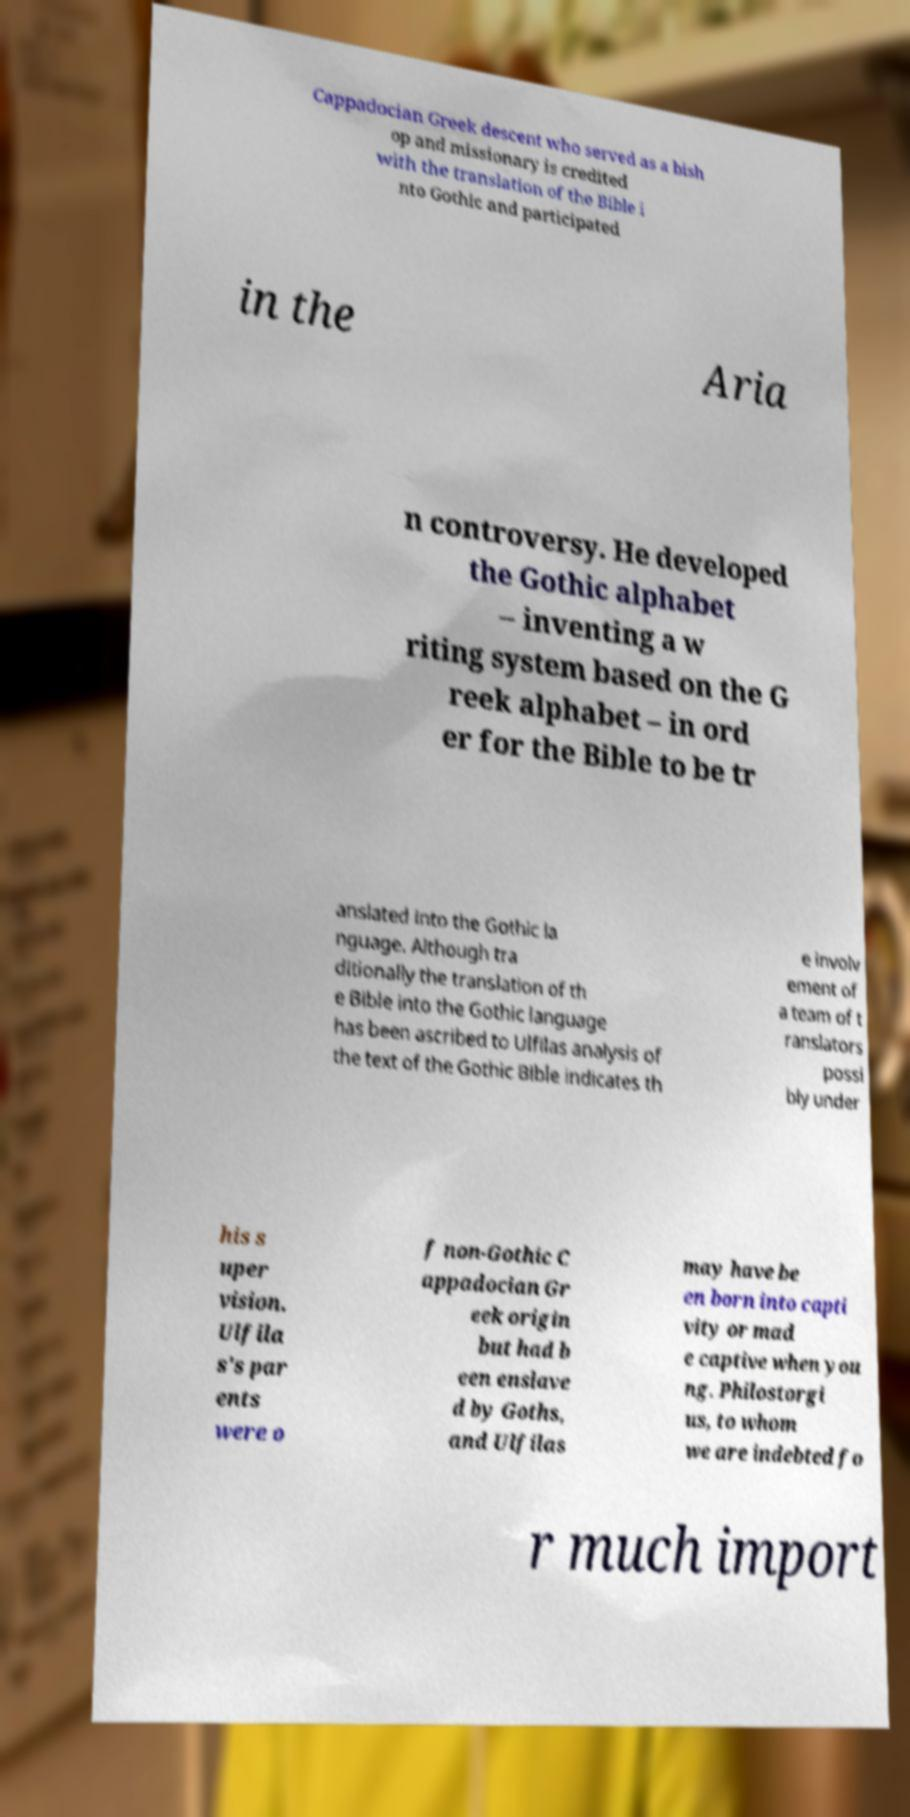Can you accurately transcribe the text from the provided image for me? Cappadocian Greek descent who served as a bish op and missionary is credited with the translation of the Bible i nto Gothic and participated in the Aria n controversy. He developed the Gothic alphabet – inventing a w riting system based on the G reek alphabet – in ord er for the Bible to be tr anslated into the Gothic la nguage. Although tra ditionally the translation of th e Bible into the Gothic language has been ascribed to Ulfilas analysis of the text of the Gothic Bible indicates th e involv ement of a team of t ranslators possi bly under his s uper vision. Ulfila s's par ents were o f non-Gothic C appadocian Gr eek origin but had b een enslave d by Goths, and Ulfilas may have be en born into capti vity or mad e captive when you ng. Philostorgi us, to whom we are indebted fo r much import 